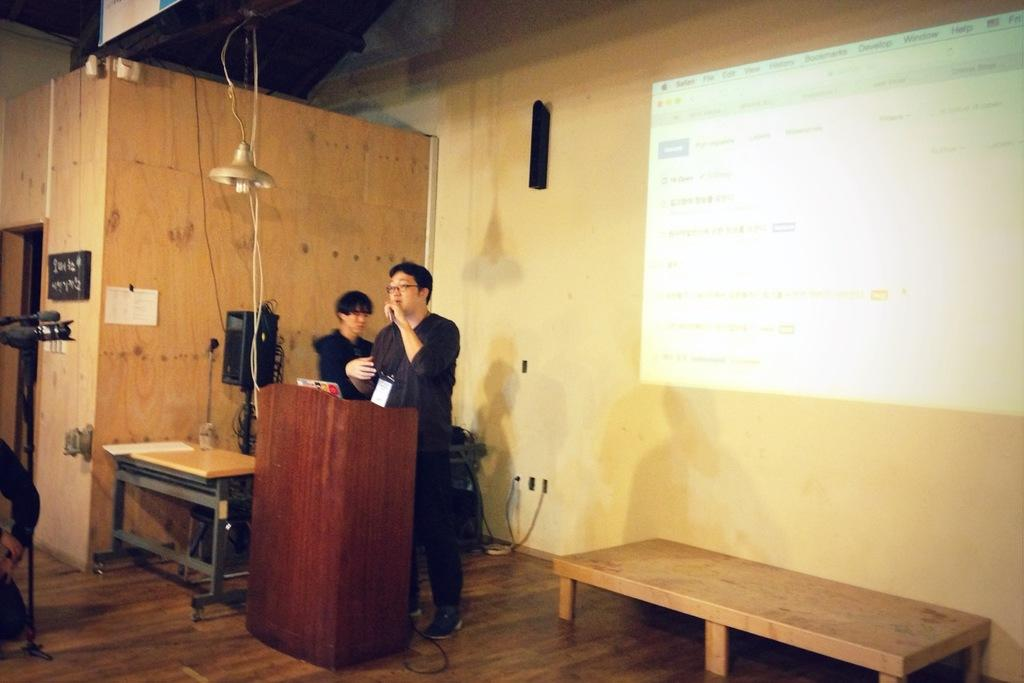What color is the wall that can be seen in the image? There is a yellow color wall in the image. What object is present on the wall? There is a screen on the wall in the image. What piece of furniture is visible in the image? There is a table in the image. How many people are present in the image? There are two people in the image. What is the property value of the house in the image? There is no information about the property value of the house in the image. How does the earthquake affect the screen in the image? There is no earthquake present in the image, so its effect on the screen cannot be determined. 